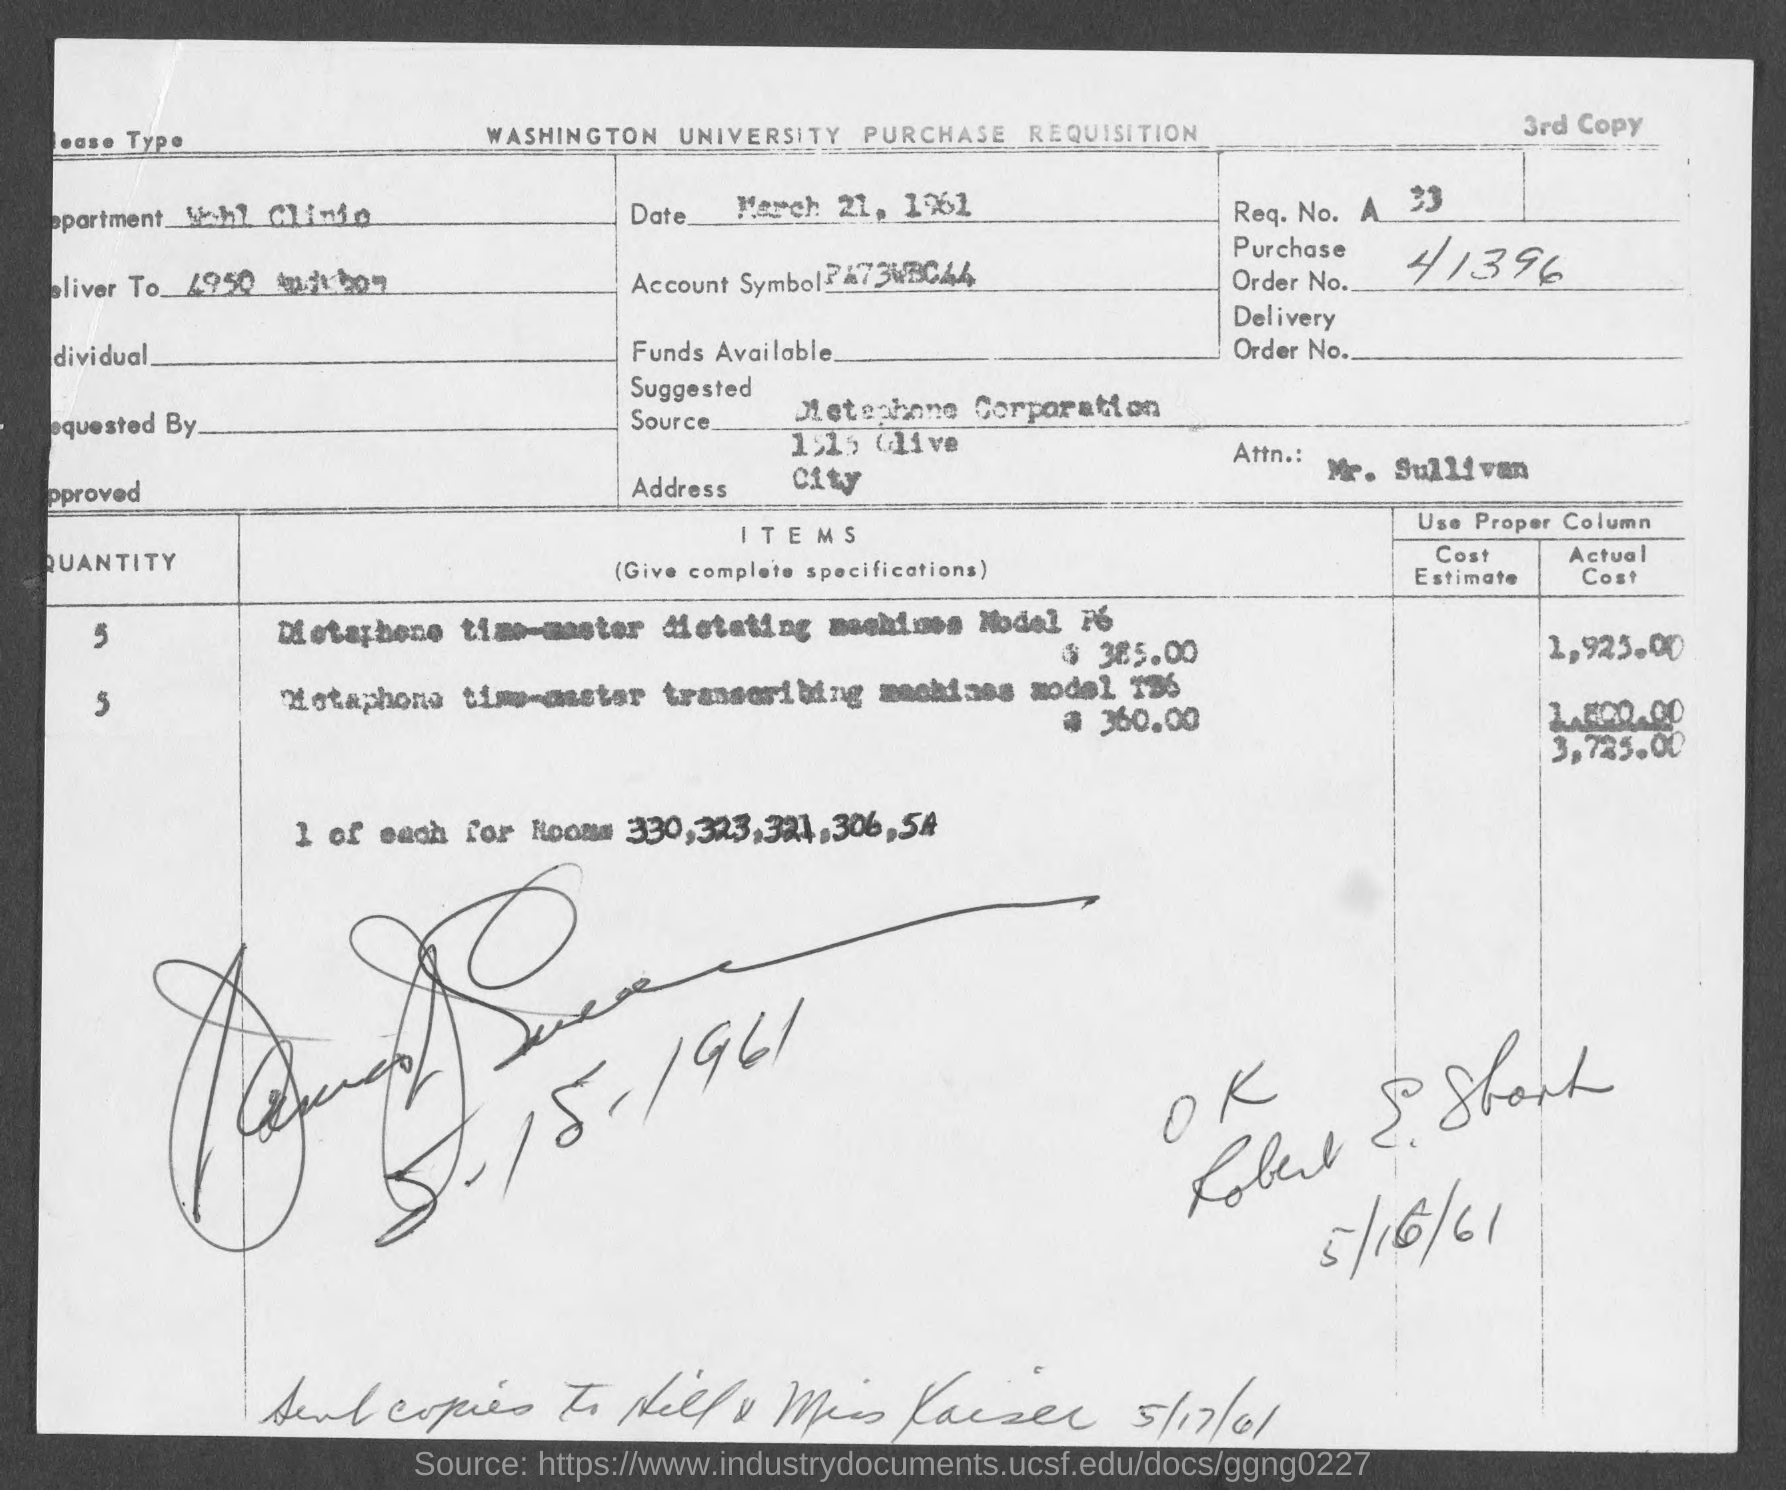What is the Req. No. given in the document?
Make the answer very short. 33. What is the Purchase Order No. given in the document?
Make the answer very short. 41396. What is the account symbol mentioned in the document?
Provide a succinct answer. PA73WBC44. What is the total actual cost mentioned in the document?
Provide a succinct answer. 3,725. 